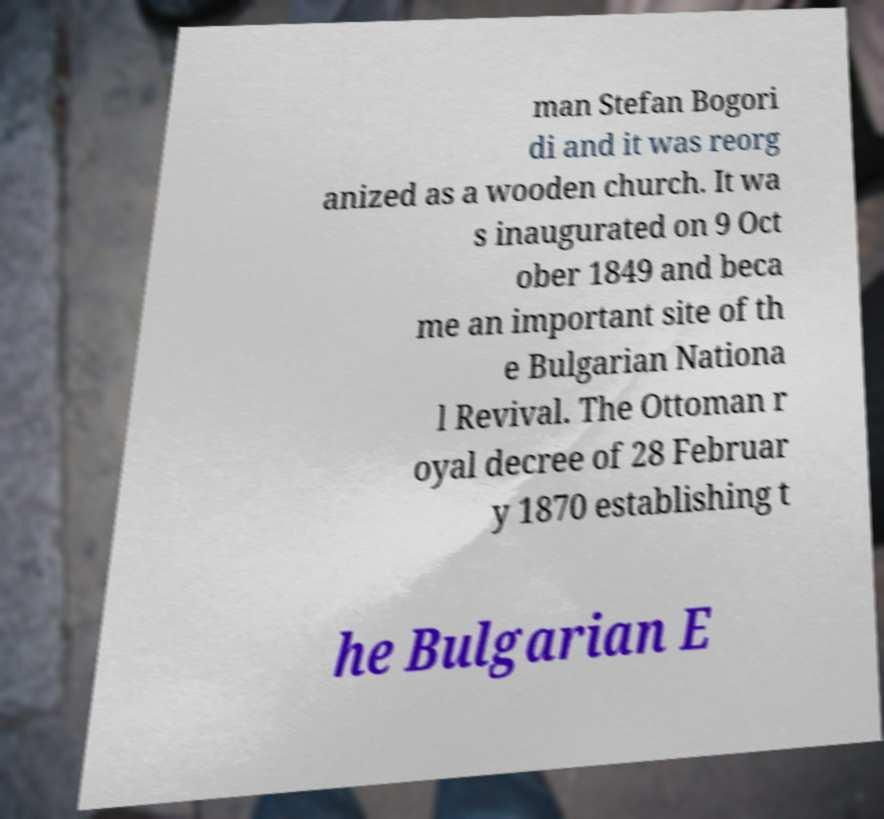Could you extract and type out the text from this image? man Stefan Bogori di and it was reorg anized as a wooden church. It wa s inaugurated on 9 Oct ober 1849 and beca me an important site of th e Bulgarian Nationa l Revival. The Ottoman r oyal decree of 28 Februar y 1870 establishing t he Bulgarian E 